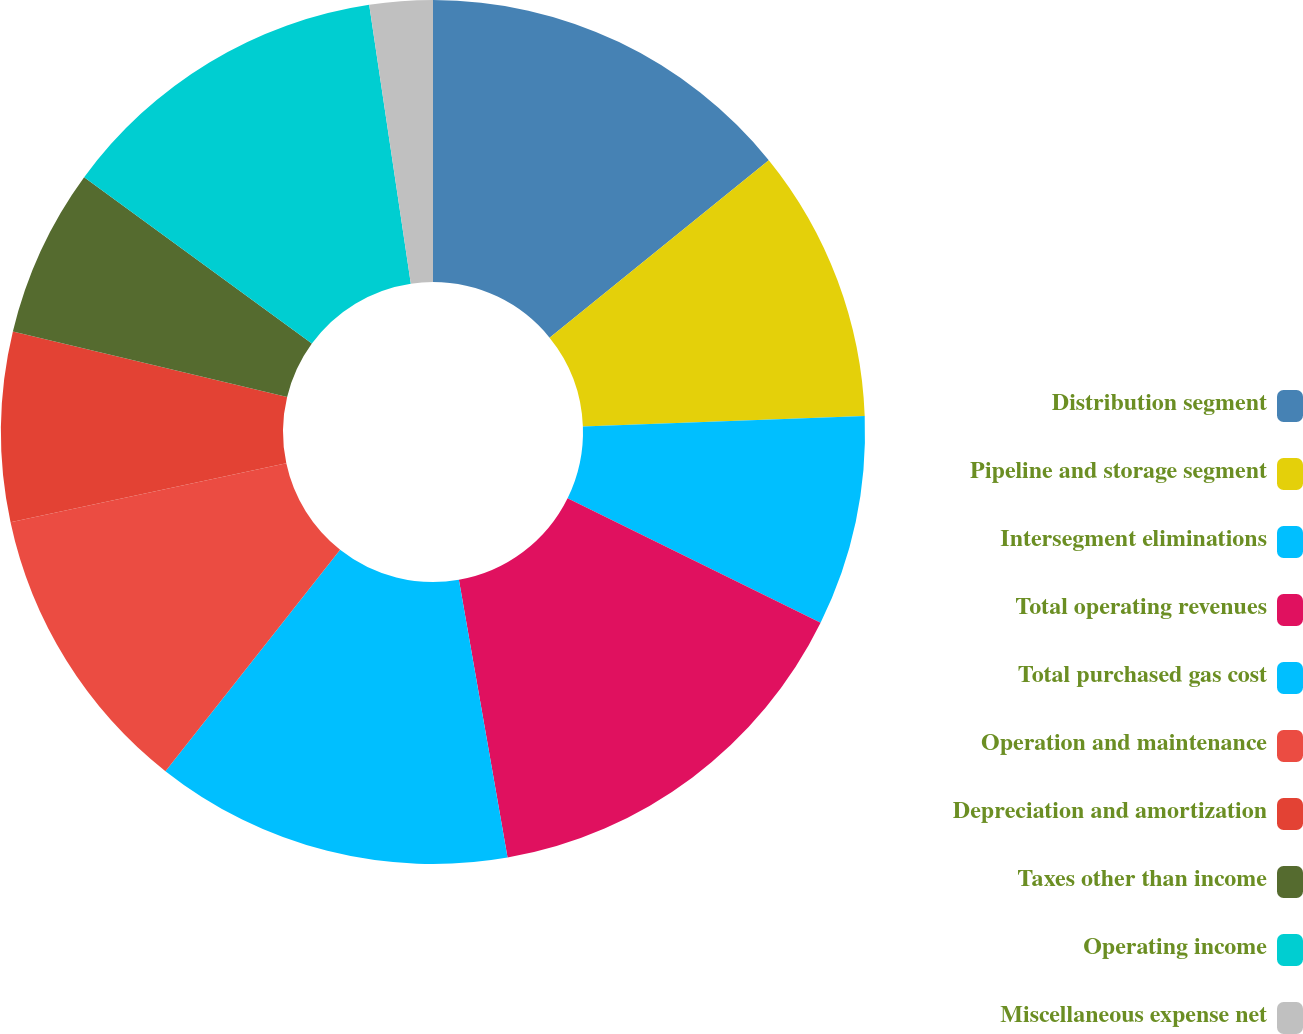Convert chart. <chart><loc_0><loc_0><loc_500><loc_500><pie_chart><fcel>Distribution segment<fcel>Pipeline and storage segment<fcel>Intersegment eliminations<fcel>Total operating revenues<fcel>Total purchased gas cost<fcel>Operation and maintenance<fcel>Depreciation and amortization<fcel>Taxes other than income<fcel>Operating income<fcel>Miscellaneous expense net<nl><fcel>14.17%<fcel>10.24%<fcel>7.87%<fcel>14.96%<fcel>13.39%<fcel>11.02%<fcel>7.09%<fcel>6.3%<fcel>12.6%<fcel>2.36%<nl></chart> 